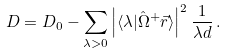<formula> <loc_0><loc_0><loc_500><loc_500>D = D _ { 0 } - \sum _ { \lambda > 0 } \left | \langle \lambda | \hat { \Omega } ^ { + } \vec { r } \rangle \right | ^ { 2 } \frac { 1 } { \lambda d } \, .</formula> 